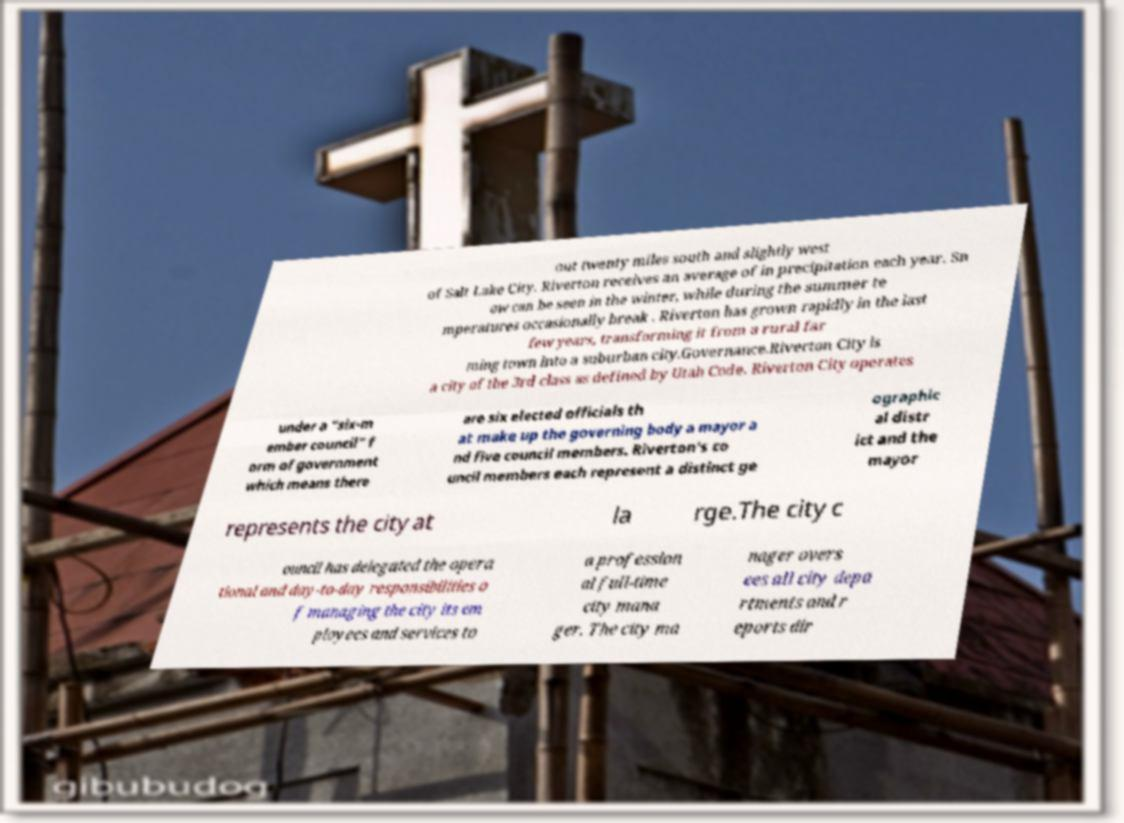I need the written content from this picture converted into text. Can you do that? out twenty miles south and slightly west of Salt Lake City. Riverton receives an average of in precipitation each year. Sn ow can be seen in the winter, while during the summer te mperatures occasionally break . Riverton has grown rapidly in the last few years, transforming it from a rural far ming town into a suburban city.Governance.Riverton City is a city of the 3rd class as defined by Utah Code. Riverton City operates under a “six-m ember council" f orm of government which means there are six elected officials th at make up the governing body a mayor a nd five council members. Riverton's co uncil members each represent a distinct ge ographic al distr ict and the mayor represents the city at la rge.The city c ouncil has delegated the opera tional and day-to-day responsibilities o f managing the city its em ployees and services to a profession al full-time city mana ger. The city ma nager overs ees all city depa rtments and r eports dir 